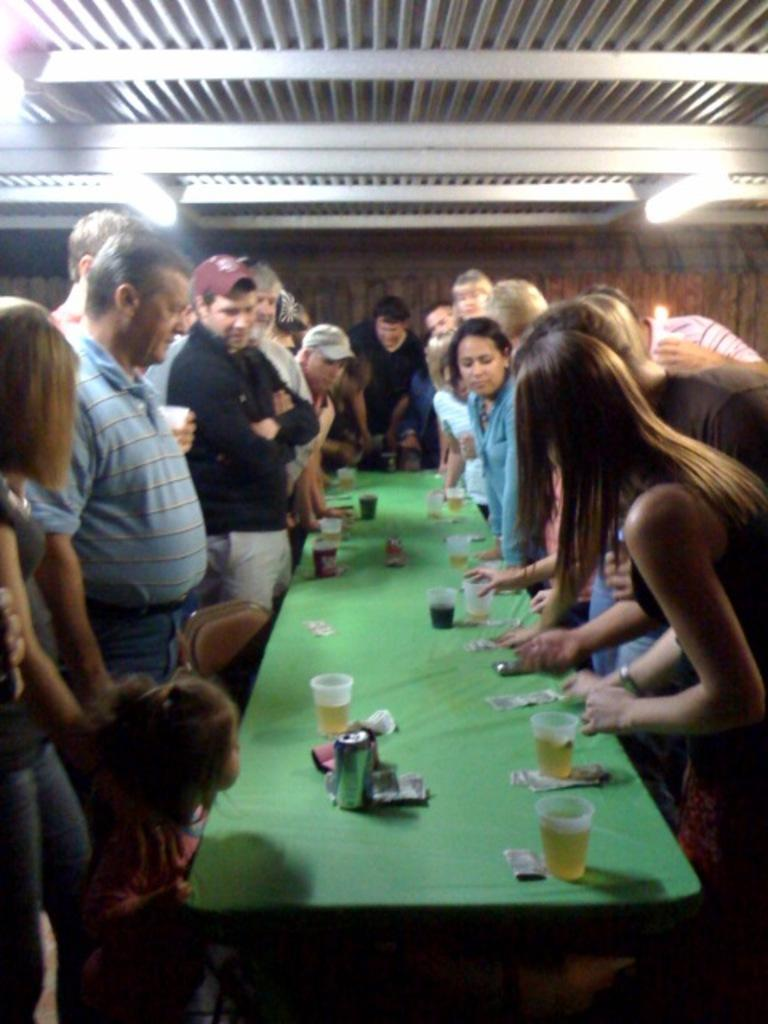What are the people doing in the image? The people are standing around a table in the image. What objects are on the table? There are glasses on the table in the image. What can be seen on the roof in the image? There are lights on the roof in the image. Can you tell me how many needles are on the table in the image? There are no needles present on the table in the image. What type of industry is depicted in the image? The image does not depict any specific industry; it shows people standing around a table with glasses on it and lights on the roof. 